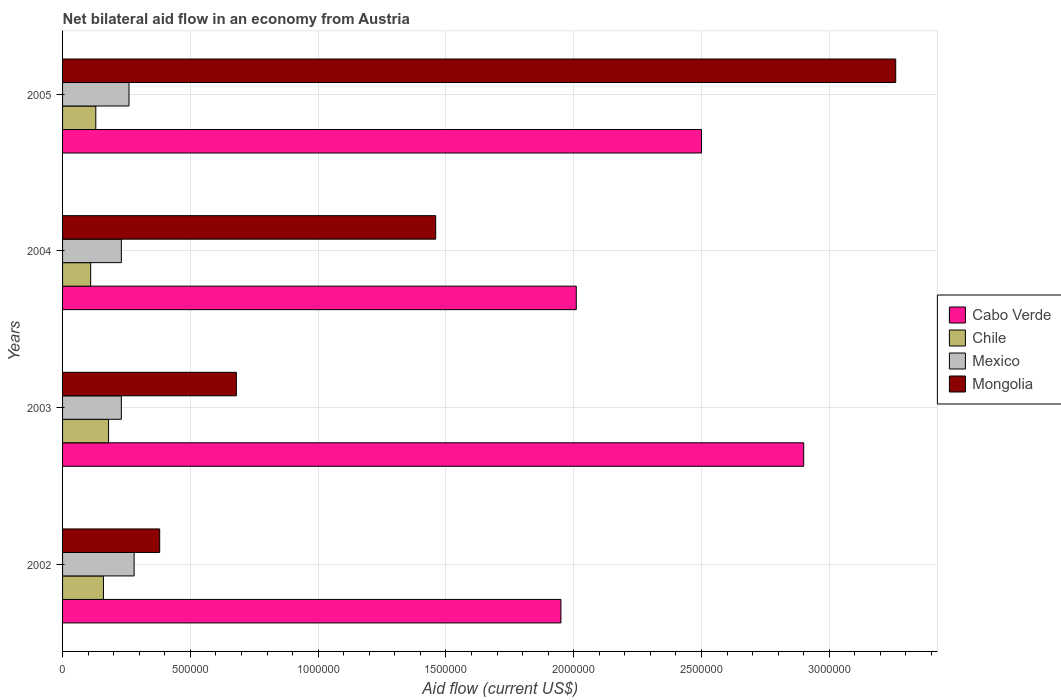How many different coloured bars are there?
Provide a short and direct response. 4. Are the number of bars on each tick of the Y-axis equal?
Make the answer very short. Yes. In how many cases, is the number of bars for a given year not equal to the number of legend labels?
Ensure brevity in your answer.  0. What is the net bilateral aid flow in Mexico in 2003?
Your answer should be very brief. 2.30e+05. Across all years, what is the maximum net bilateral aid flow in Mongolia?
Keep it short and to the point. 3.26e+06. Across all years, what is the minimum net bilateral aid flow in Chile?
Offer a terse response. 1.10e+05. In which year was the net bilateral aid flow in Mongolia minimum?
Provide a succinct answer. 2002. What is the total net bilateral aid flow in Mexico in the graph?
Your response must be concise. 1.00e+06. What is the difference between the net bilateral aid flow in Mongolia in 2003 and that in 2004?
Give a very brief answer. -7.80e+05. What is the difference between the net bilateral aid flow in Mongolia in 2004 and the net bilateral aid flow in Cabo Verde in 2005?
Offer a terse response. -1.04e+06. What is the average net bilateral aid flow in Chile per year?
Give a very brief answer. 1.45e+05. In the year 2004, what is the difference between the net bilateral aid flow in Mexico and net bilateral aid flow in Mongolia?
Make the answer very short. -1.23e+06. In how many years, is the net bilateral aid flow in Cabo Verde greater than 700000 US$?
Make the answer very short. 4. What is the ratio of the net bilateral aid flow in Cabo Verde in 2003 to that in 2004?
Keep it short and to the point. 1.44. Is the net bilateral aid flow in Mexico in 2002 less than that in 2004?
Make the answer very short. No. Is the difference between the net bilateral aid flow in Mexico in 2003 and 2005 greater than the difference between the net bilateral aid flow in Mongolia in 2003 and 2005?
Your response must be concise. Yes. What is the difference between the highest and the second highest net bilateral aid flow in Mongolia?
Make the answer very short. 1.80e+06. What is the difference between the highest and the lowest net bilateral aid flow in Cabo Verde?
Make the answer very short. 9.50e+05. In how many years, is the net bilateral aid flow in Cabo Verde greater than the average net bilateral aid flow in Cabo Verde taken over all years?
Your answer should be compact. 2. Is the sum of the net bilateral aid flow in Mongolia in 2002 and 2005 greater than the maximum net bilateral aid flow in Mexico across all years?
Your response must be concise. Yes. Is it the case that in every year, the sum of the net bilateral aid flow in Mongolia and net bilateral aid flow in Chile is greater than the sum of net bilateral aid flow in Mexico and net bilateral aid flow in Cabo Verde?
Your response must be concise. No. What does the 3rd bar from the top in 2002 represents?
Ensure brevity in your answer.  Chile. What does the 4th bar from the bottom in 2003 represents?
Offer a very short reply. Mongolia. How many years are there in the graph?
Your answer should be very brief. 4. What is the difference between two consecutive major ticks on the X-axis?
Give a very brief answer. 5.00e+05. Are the values on the major ticks of X-axis written in scientific E-notation?
Make the answer very short. No. What is the title of the graph?
Make the answer very short. Net bilateral aid flow in an economy from Austria. What is the label or title of the Y-axis?
Your answer should be compact. Years. What is the Aid flow (current US$) in Cabo Verde in 2002?
Your response must be concise. 1.95e+06. What is the Aid flow (current US$) in Chile in 2002?
Your response must be concise. 1.60e+05. What is the Aid flow (current US$) of Mexico in 2002?
Provide a succinct answer. 2.80e+05. What is the Aid flow (current US$) in Mongolia in 2002?
Provide a succinct answer. 3.80e+05. What is the Aid flow (current US$) of Cabo Verde in 2003?
Provide a succinct answer. 2.90e+06. What is the Aid flow (current US$) of Chile in 2003?
Make the answer very short. 1.80e+05. What is the Aid flow (current US$) in Mongolia in 2003?
Provide a succinct answer. 6.80e+05. What is the Aid flow (current US$) of Cabo Verde in 2004?
Your answer should be compact. 2.01e+06. What is the Aid flow (current US$) in Chile in 2004?
Provide a short and direct response. 1.10e+05. What is the Aid flow (current US$) of Mongolia in 2004?
Provide a short and direct response. 1.46e+06. What is the Aid flow (current US$) in Cabo Verde in 2005?
Make the answer very short. 2.50e+06. What is the Aid flow (current US$) of Mexico in 2005?
Keep it short and to the point. 2.60e+05. What is the Aid flow (current US$) of Mongolia in 2005?
Your answer should be compact. 3.26e+06. Across all years, what is the maximum Aid flow (current US$) of Cabo Verde?
Give a very brief answer. 2.90e+06. Across all years, what is the maximum Aid flow (current US$) of Chile?
Make the answer very short. 1.80e+05. Across all years, what is the maximum Aid flow (current US$) in Mexico?
Offer a terse response. 2.80e+05. Across all years, what is the maximum Aid flow (current US$) of Mongolia?
Make the answer very short. 3.26e+06. Across all years, what is the minimum Aid flow (current US$) of Cabo Verde?
Make the answer very short. 1.95e+06. Across all years, what is the minimum Aid flow (current US$) of Chile?
Your answer should be very brief. 1.10e+05. What is the total Aid flow (current US$) in Cabo Verde in the graph?
Your answer should be compact. 9.36e+06. What is the total Aid flow (current US$) in Chile in the graph?
Your answer should be compact. 5.80e+05. What is the total Aid flow (current US$) in Mexico in the graph?
Offer a terse response. 1.00e+06. What is the total Aid flow (current US$) in Mongolia in the graph?
Provide a succinct answer. 5.78e+06. What is the difference between the Aid flow (current US$) in Cabo Verde in 2002 and that in 2003?
Offer a terse response. -9.50e+05. What is the difference between the Aid flow (current US$) in Mexico in 2002 and that in 2003?
Your response must be concise. 5.00e+04. What is the difference between the Aid flow (current US$) of Mongolia in 2002 and that in 2003?
Offer a terse response. -3.00e+05. What is the difference between the Aid flow (current US$) in Cabo Verde in 2002 and that in 2004?
Ensure brevity in your answer.  -6.00e+04. What is the difference between the Aid flow (current US$) of Chile in 2002 and that in 2004?
Make the answer very short. 5.00e+04. What is the difference between the Aid flow (current US$) in Mexico in 2002 and that in 2004?
Provide a short and direct response. 5.00e+04. What is the difference between the Aid flow (current US$) in Mongolia in 2002 and that in 2004?
Provide a succinct answer. -1.08e+06. What is the difference between the Aid flow (current US$) in Cabo Verde in 2002 and that in 2005?
Make the answer very short. -5.50e+05. What is the difference between the Aid flow (current US$) in Chile in 2002 and that in 2005?
Keep it short and to the point. 3.00e+04. What is the difference between the Aid flow (current US$) in Mongolia in 2002 and that in 2005?
Provide a succinct answer. -2.88e+06. What is the difference between the Aid flow (current US$) in Cabo Verde in 2003 and that in 2004?
Offer a terse response. 8.90e+05. What is the difference between the Aid flow (current US$) in Chile in 2003 and that in 2004?
Your answer should be compact. 7.00e+04. What is the difference between the Aid flow (current US$) of Mexico in 2003 and that in 2004?
Your answer should be very brief. 0. What is the difference between the Aid flow (current US$) in Mongolia in 2003 and that in 2004?
Offer a terse response. -7.80e+05. What is the difference between the Aid flow (current US$) in Cabo Verde in 2003 and that in 2005?
Ensure brevity in your answer.  4.00e+05. What is the difference between the Aid flow (current US$) of Mexico in 2003 and that in 2005?
Your answer should be very brief. -3.00e+04. What is the difference between the Aid flow (current US$) in Mongolia in 2003 and that in 2005?
Keep it short and to the point. -2.58e+06. What is the difference between the Aid flow (current US$) in Cabo Verde in 2004 and that in 2005?
Your answer should be compact. -4.90e+05. What is the difference between the Aid flow (current US$) in Mexico in 2004 and that in 2005?
Offer a terse response. -3.00e+04. What is the difference between the Aid flow (current US$) in Mongolia in 2004 and that in 2005?
Ensure brevity in your answer.  -1.80e+06. What is the difference between the Aid flow (current US$) in Cabo Verde in 2002 and the Aid flow (current US$) in Chile in 2003?
Give a very brief answer. 1.77e+06. What is the difference between the Aid flow (current US$) of Cabo Verde in 2002 and the Aid flow (current US$) of Mexico in 2003?
Provide a short and direct response. 1.72e+06. What is the difference between the Aid flow (current US$) in Cabo Verde in 2002 and the Aid flow (current US$) in Mongolia in 2003?
Provide a succinct answer. 1.27e+06. What is the difference between the Aid flow (current US$) of Chile in 2002 and the Aid flow (current US$) of Mongolia in 2003?
Your response must be concise. -5.20e+05. What is the difference between the Aid flow (current US$) of Mexico in 2002 and the Aid flow (current US$) of Mongolia in 2003?
Keep it short and to the point. -4.00e+05. What is the difference between the Aid flow (current US$) of Cabo Verde in 2002 and the Aid flow (current US$) of Chile in 2004?
Your response must be concise. 1.84e+06. What is the difference between the Aid flow (current US$) of Cabo Verde in 2002 and the Aid flow (current US$) of Mexico in 2004?
Give a very brief answer. 1.72e+06. What is the difference between the Aid flow (current US$) of Cabo Verde in 2002 and the Aid flow (current US$) of Mongolia in 2004?
Offer a terse response. 4.90e+05. What is the difference between the Aid flow (current US$) of Chile in 2002 and the Aid flow (current US$) of Mongolia in 2004?
Your answer should be compact. -1.30e+06. What is the difference between the Aid flow (current US$) in Mexico in 2002 and the Aid flow (current US$) in Mongolia in 2004?
Provide a succinct answer. -1.18e+06. What is the difference between the Aid flow (current US$) in Cabo Verde in 2002 and the Aid flow (current US$) in Chile in 2005?
Provide a short and direct response. 1.82e+06. What is the difference between the Aid flow (current US$) of Cabo Verde in 2002 and the Aid flow (current US$) of Mexico in 2005?
Your answer should be compact. 1.69e+06. What is the difference between the Aid flow (current US$) in Cabo Verde in 2002 and the Aid flow (current US$) in Mongolia in 2005?
Provide a succinct answer. -1.31e+06. What is the difference between the Aid flow (current US$) in Chile in 2002 and the Aid flow (current US$) in Mexico in 2005?
Make the answer very short. -1.00e+05. What is the difference between the Aid flow (current US$) in Chile in 2002 and the Aid flow (current US$) in Mongolia in 2005?
Provide a succinct answer. -3.10e+06. What is the difference between the Aid flow (current US$) in Mexico in 2002 and the Aid flow (current US$) in Mongolia in 2005?
Provide a succinct answer. -2.98e+06. What is the difference between the Aid flow (current US$) in Cabo Verde in 2003 and the Aid flow (current US$) in Chile in 2004?
Give a very brief answer. 2.79e+06. What is the difference between the Aid flow (current US$) of Cabo Verde in 2003 and the Aid flow (current US$) of Mexico in 2004?
Make the answer very short. 2.67e+06. What is the difference between the Aid flow (current US$) in Cabo Verde in 2003 and the Aid flow (current US$) in Mongolia in 2004?
Your answer should be compact. 1.44e+06. What is the difference between the Aid flow (current US$) in Chile in 2003 and the Aid flow (current US$) in Mexico in 2004?
Your answer should be very brief. -5.00e+04. What is the difference between the Aid flow (current US$) of Chile in 2003 and the Aid flow (current US$) of Mongolia in 2004?
Offer a terse response. -1.28e+06. What is the difference between the Aid flow (current US$) in Mexico in 2003 and the Aid flow (current US$) in Mongolia in 2004?
Give a very brief answer. -1.23e+06. What is the difference between the Aid flow (current US$) of Cabo Verde in 2003 and the Aid flow (current US$) of Chile in 2005?
Provide a succinct answer. 2.77e+06. What is the difference between the Aid flow (current US$) of Cabo Verde in 2003 and the Aid flow (current US$) of Mexico in 2005?
Keep it short and to the point. 2.64e+06. What is the difference between the Aid flow (current US$) in Cabo Verde in 2003 and the Aid flow (current US$) in Mongolia in 2005?
Your answer should be compact. -3.60e+05. What is the difference between the Aid flow (current US$) in Chile in 2003 and the Aid flow (current US$) in Mongolia in 2005?
Your answer should be compact. -3.08e+06. What is the difference between the Aid flow (current US$) of Mexico in 2003 and the Aid flow (current US$) of Mongolia in 2005?
Provide a succinct answer. -3.03e+06. What is the difference between the Aid flow (current US$) in Cabo Verde in 2004 and the Aid flow (current US$) in Chile in 2005?
Ensure brevity in your answer.  1.88e+06. What is the difference between the Aid flow (current US$) of Cabo Verde in 2004 and the Aid flow (current US$) of Mexico in 2005?
Your answer should be compact. 1.75e+06. What is the difference between the Aid flow (current US$) in Cabo Verde in 2004 and the Aid flow (current US$) in Mongolia in 2005?
Provide a succinct answer. -1.25e+06. What is the difference between the Aid flow (current US$) in Chile in 2004 and the Aid flow (current US$) in Mexico in 2005?
Make the answer very short. -1.50e+05. What is the difference between the Aid flow (current US$) of Chile in 2004 and the Aid flow (current US$) of Mongolia in 2005?
Ensure brevity in your answer.  -3.15e+06. What is the difference between the Aid flow (current US$) in Mexico in 2004 and the Aid flow (current US$) in Mongolia in 2005?
Offer a very short reply. -3.03e+06. What is the average Aid flow (current US$) in Cabo Verde per year?
Provide a short and direct response. 2.34e+06. What is the average Aid flow (current US$) in Chile per year?
Provide a short and direct response. 1.45e+05. What is the average Aid flow (current US$) of Mongolia per year?
Your response must be concise. 1.44e+06. In the year 2002, what is the difference between the Aid flow (current US$) in Cabo Verde and Aid flow (current US$) in Chile?
Offer a terse response. 1.79e+06. In the year 2002, what is the difference between the Aid flow (current US$) in Cabo Verde and Aid flow (current US$) in Mexico?
Offer a very short reply. 1.67e+06. In the year 2002, what is the difference between the Aid flow (current US$) of Cabo Verde and Aid flow (current US$) of Mongolia?
Offer a very short reply. 1.57e+06. In the year 2003, what is the difference between the Aid flow (current US$) of Cabo Verde and Aid flow (current US$) of Chile?
Ensure brevity in your answer.  2.72e+06. In the year 2003, what is the difference between the Aid flow (current US$) of Cabo Verde and Aid flow (current US$) of Mexico?
Make the answer very short. 2.67e+06. In the year 2003, what is the difference between the Aid flow (current US$) of Cabo Verde and Aid flow (current US$) of Mongolia?
Your answer should be very brief. 2.22e+06. In the year 2003, what is the difference between the Aid flow (current US$) of Chile and Aid flow (current US$) of Mexico?
Your response must be concise. -5.00e+04. In the year 2003, what is the difference between the Aid flow (current US$) of Chile and Aid flow (current US$) of Mongolia?
Your answer should be very brief. -5.00e+05. In the year 2003, what is the difference between the Aid flow (current US$) in Mexico and Aid flow (current US$) in Mongolia?
Give a very brief answer. -4.50e+05. In the year 2004, what is the difference between the Aid flow (current US$) in Cabo Verde and Aid flow (current US$) in Chile?
Your answer should be very brief. 1.90e+06. In the year 2004, what is the difference between the Aid flow (current US$) in Cabo Verde and Aid flow (current US$) in Mexico?
Offer a terse response. 1.78e+06. In the year 2004, what is the difference between the Aid flow (current US$) of Cabo Verde and Aid flow (current US$) of Mongolia?
Your response must be concise. 5.50e+05. In the year 2004, what is the difference between the Aid flow (current US$) of Chile and Aid flow (current US$) of Mexico?
Your response must be concise. -1.20e+05. In the year 2004, what is the difference between the Aid flow (current US$) of Chile and Aid flow (current US$) of Mongolia?
Your answer should be very brief. -1.35e+06. In the year 2004, what is the difference between the Aid flow (current US$) of Mexico and Aid flow (current US$) of Mongolia?
Ensure brevity in your answer.  -1.23e+06. In the year 2005, what is the difference between the Aid flow (current US$) in Cabo Verde and Aid flow (current US$) in Chile?
Give a very brief answer. 2.37e+06. In the year 2005, what is the difference between the Aid flow (current US$) of Cabo Verde and Aid flow (current US$) of Mexico?
Give a very brief answer. 2.24e+06. In the year 2005, what is the difference between the Aid flow (current US$) of Cabo Verde and Aid flow (current US$) of Mongolia?
Keep it short and to the point. -7.60e+05. In the year 2005, what is the difference between the Aid flow (current US$) of Chile and Aid flow (current US$) of Mexico?
Your answer should be compact. -1.30e+05. In the year 2005, what is the difference between the Aid flow (current US$) in Chile and Aid flow (current US$) in Mongolia?
Make the answer very short. -3.13e+06. In the year 2005, what is the difference between the Aid flow (current US$) in Mexico and Aid flow (current US$) in Mongolia?
Give a very brief answer. -3.00e+06. What is the ratio of the Aid flow (current US$) in Cabo Verde in 2002 to that in 2003?
Your answer should be very brief. 0.67. What is the ratio of the Aid flow (current US$) of Chile in 2002 to that in 2003?
Keep it short and to the point. 0.89. What is the ratio of the Aid flow (current US$) of Mexico in 2002 to that in 2003?
Provide a succinct answer. 1.22. What is the ratio of the Aid flow (current US$) of Mongolia in 2002 to that in 2003?
Your response must be concise. 0.56. What is the ratio of the Aid flow (current US$) in Cabo Verde in 2002 to that in 2004?
Provide a succinct answer. 0.97. What is the ratio of the Aid flow (current US$) of Chile in 2002 to that in 2004?
Make the answer very short. 1.45. What is the ratio of the Aid flow (current US$) in Mexico in 2002 to that in 2004?
Provide a short and direct response. 1.22. What is the ratio of the Aid flow (current US$) of Mongolia in 2002 to that in 2004?
Offer a terse response. 0.26. What is the ratio of the Aid flow (current US$) in Cabo Verde in 2002 to that in 2005?
Ensure brevity in your answer.  0.78. What is the ratio of the Aid flow (current US$) of Chile in 2002 to that in 2005?
Offer a terse response. 1.23. What is the ratio of the Aid flow (current US$) in Mexico in 2002 to that in 2005?
Your answer should be compact. 1.08. What is the ratio of the Aid flow (current US$) in Mongolia in 2002 to that in 2005?
Give a very brief answer. 0.12. What is the ratio of the Aid flow (current US$) of Cabo Verde in 2003 to that in 2004?
Offer a very short reply. 1.44. What is the ratio of the Aid flow (current US$) in Chile in 2003 to that in 2004?
Your response must be concise. 1.64. What is the ratio of the Aid flow (current US$) in Mongolia in 2003 to that in 2004?
Keep it short and to the point. 0.47. What is the ratio of the Aid flow (current US$) of Cabo Verde in 2003 to that in 2005?
Ensure brevity in your answer.  1.16. What is the ratio of the Aid flow (current US$) of Chile in 2003 to that in 2005?
Ensure brevity in your answer.  1.38. What is the ratio of the Aid flow (current US$) of Mexico in 2003 to that in 2005?
Your answer should be compact. 0.88. What is the ratio of the Aid flow (current US$) in Mongolia in 2003 to that in 2005?
Make the answer very short. 0.21. What is the ratio of the Aid flow (current US$) in Cabo Verde in 2004 to that in 2005?
Offer a very short reply. 0.8. What is the ratio of the Aid flow (current US$) of Chile in 2004 to that in 2005?
Keep it short and to the point. 0.85. What is the ratio of the Aid flow (current US$) of Mexico in 2004 to that in 2005?
Ensure brevity in your answer.  0.88. What is the ratio of the Aid flow (current US$) of Mongolia in 2004 to that in 2005?
Keep it short and to the point. 0.45. What is the difference between the highest and the second highest Aid flow (current US$) of Cabo Verde?
Offer a terse response. 4.00e+05. What is the difference between the highest and the second highest Aid flow (current US$) of Chile?
Give a very brief answer. 2.00e+04. What is the difference between the highest and the second highest Aid flow (current US$) of Mexico?
Give a very brief answer. 2.00e+04. What is the difference between the highest and the second highest Aid flow (current US$) in Mongolia?
Your answer should be very brief. 1.80e+06. What is the difference between the highest and the lowest Aid flow (current US$) in Cabo Verde?
Keep it short and to the point. 9.50e+05. What is the difference between the highest and the lowest Aid flow (current US$) of Chile?
Offer a very short reply. 7.00e+04. What is the difference between the highest and the lowest Aid flow (current US$) in Mongolia?
Make the answer very short. 2.88e+06. 